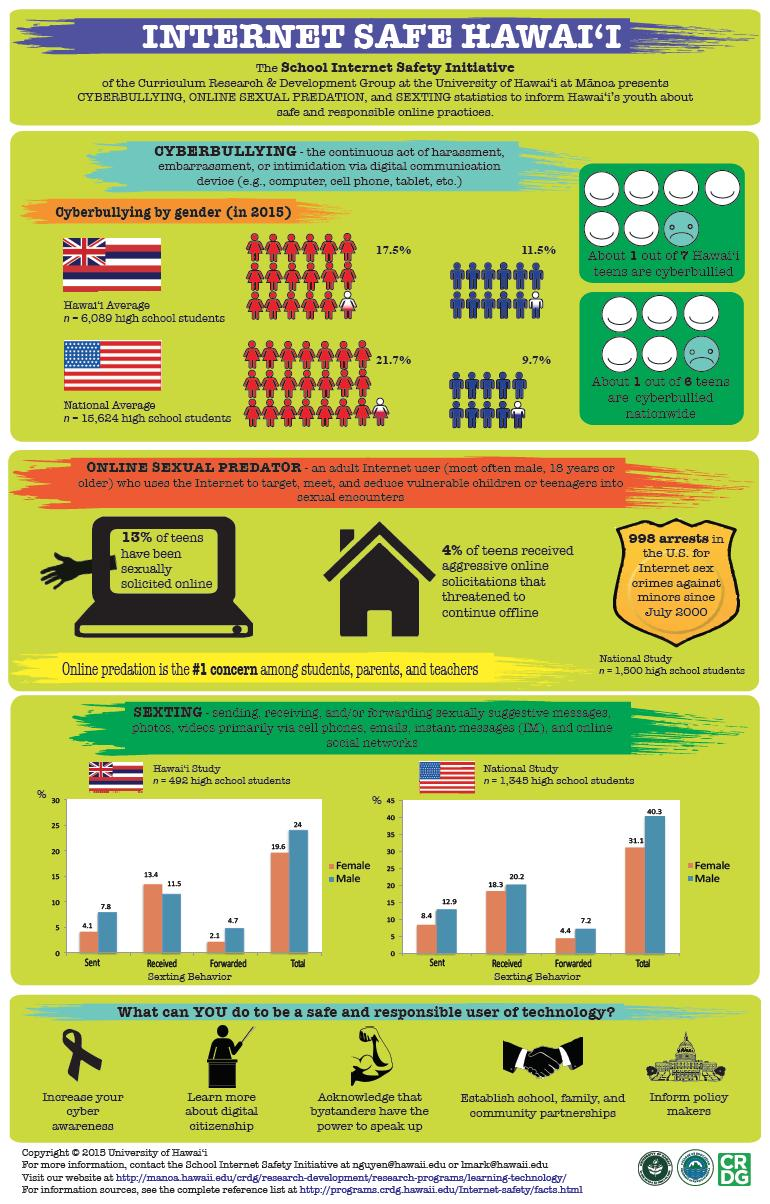Indicate a few pertinent items in this graphic. A recent study in the United States found that 12% of girls and 10% of boys have been cyberbullied. In Hawaii, there is a 6% difference in the rate at which girls and boys are cyberbullied. According to recent data, only 7.2% of boys in the US were found to be forwarding sexts, a concerning trend that highlights the need for education and awareness about digital sexual behavior among young people. According to the given data, in Hawaii, the percentage of girls receiving sexts was 13.4%. 